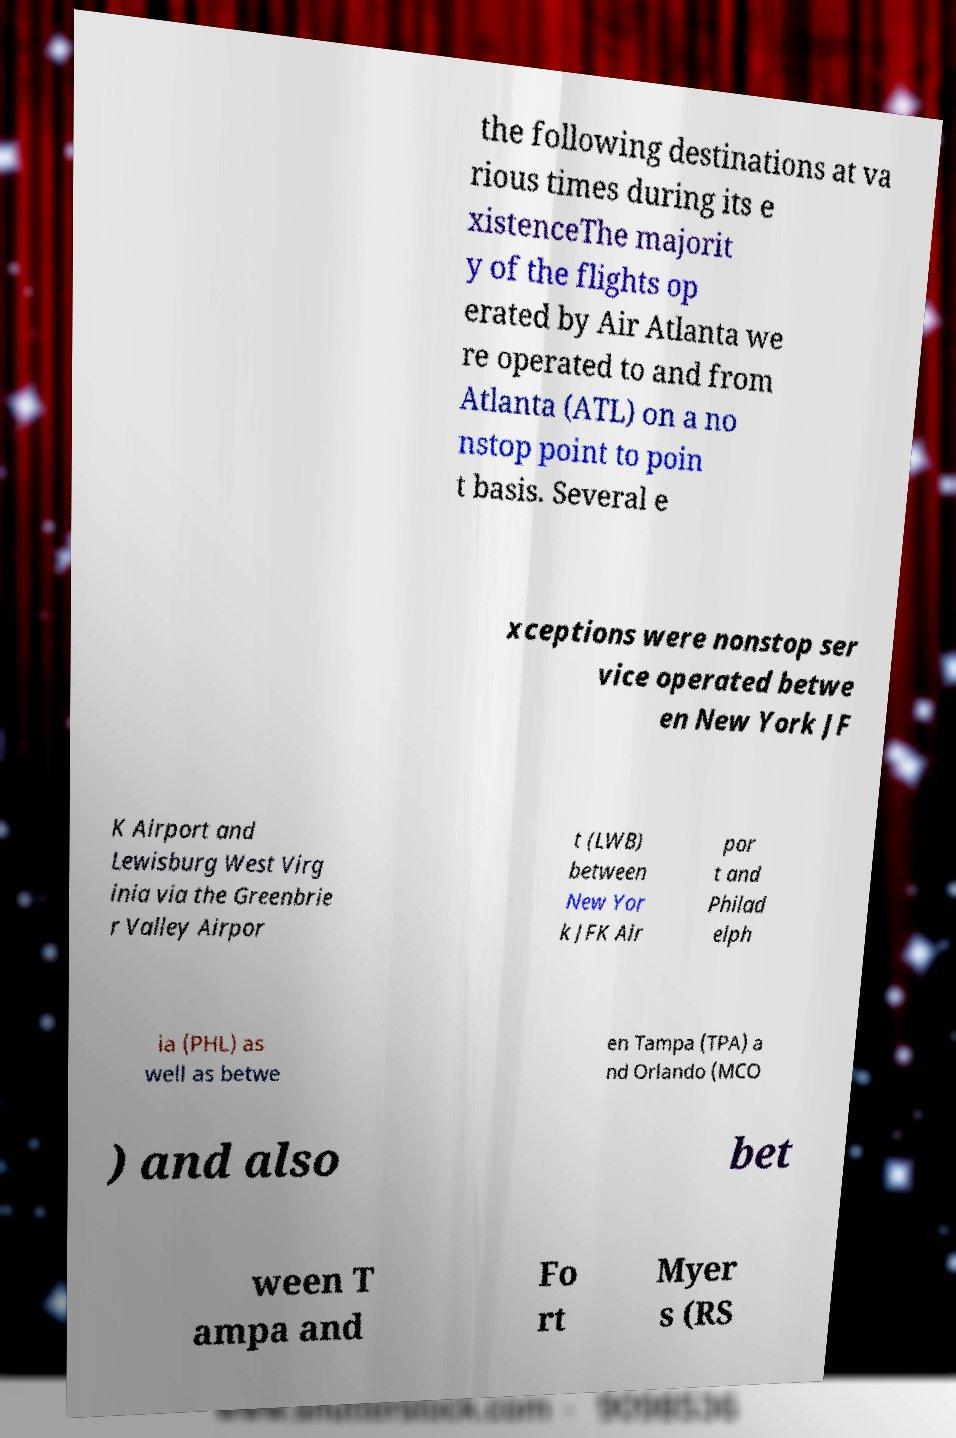Can you accurately transcribe the text from the provided image for me? the following destinations at va rious times during its e xistenceThe majorit y of the flights op erated by Air Atlanta we re operated to and from Atlanta (ATL) on a no nstop point to poin t basis. Several e xceptions were nonstop ser vice operated betwe en New York JF K Airport and Lewisburg West Virg inia via the Greenbrie r Valley Airpor t (LWB) between New Yor k JFK Air por t and Philad elph ia (PHL) as well as betwe en Tampa (TPA) a nd Orlando (MCO ) and also bet ween T ampa and Fo rt Myer s (RS 